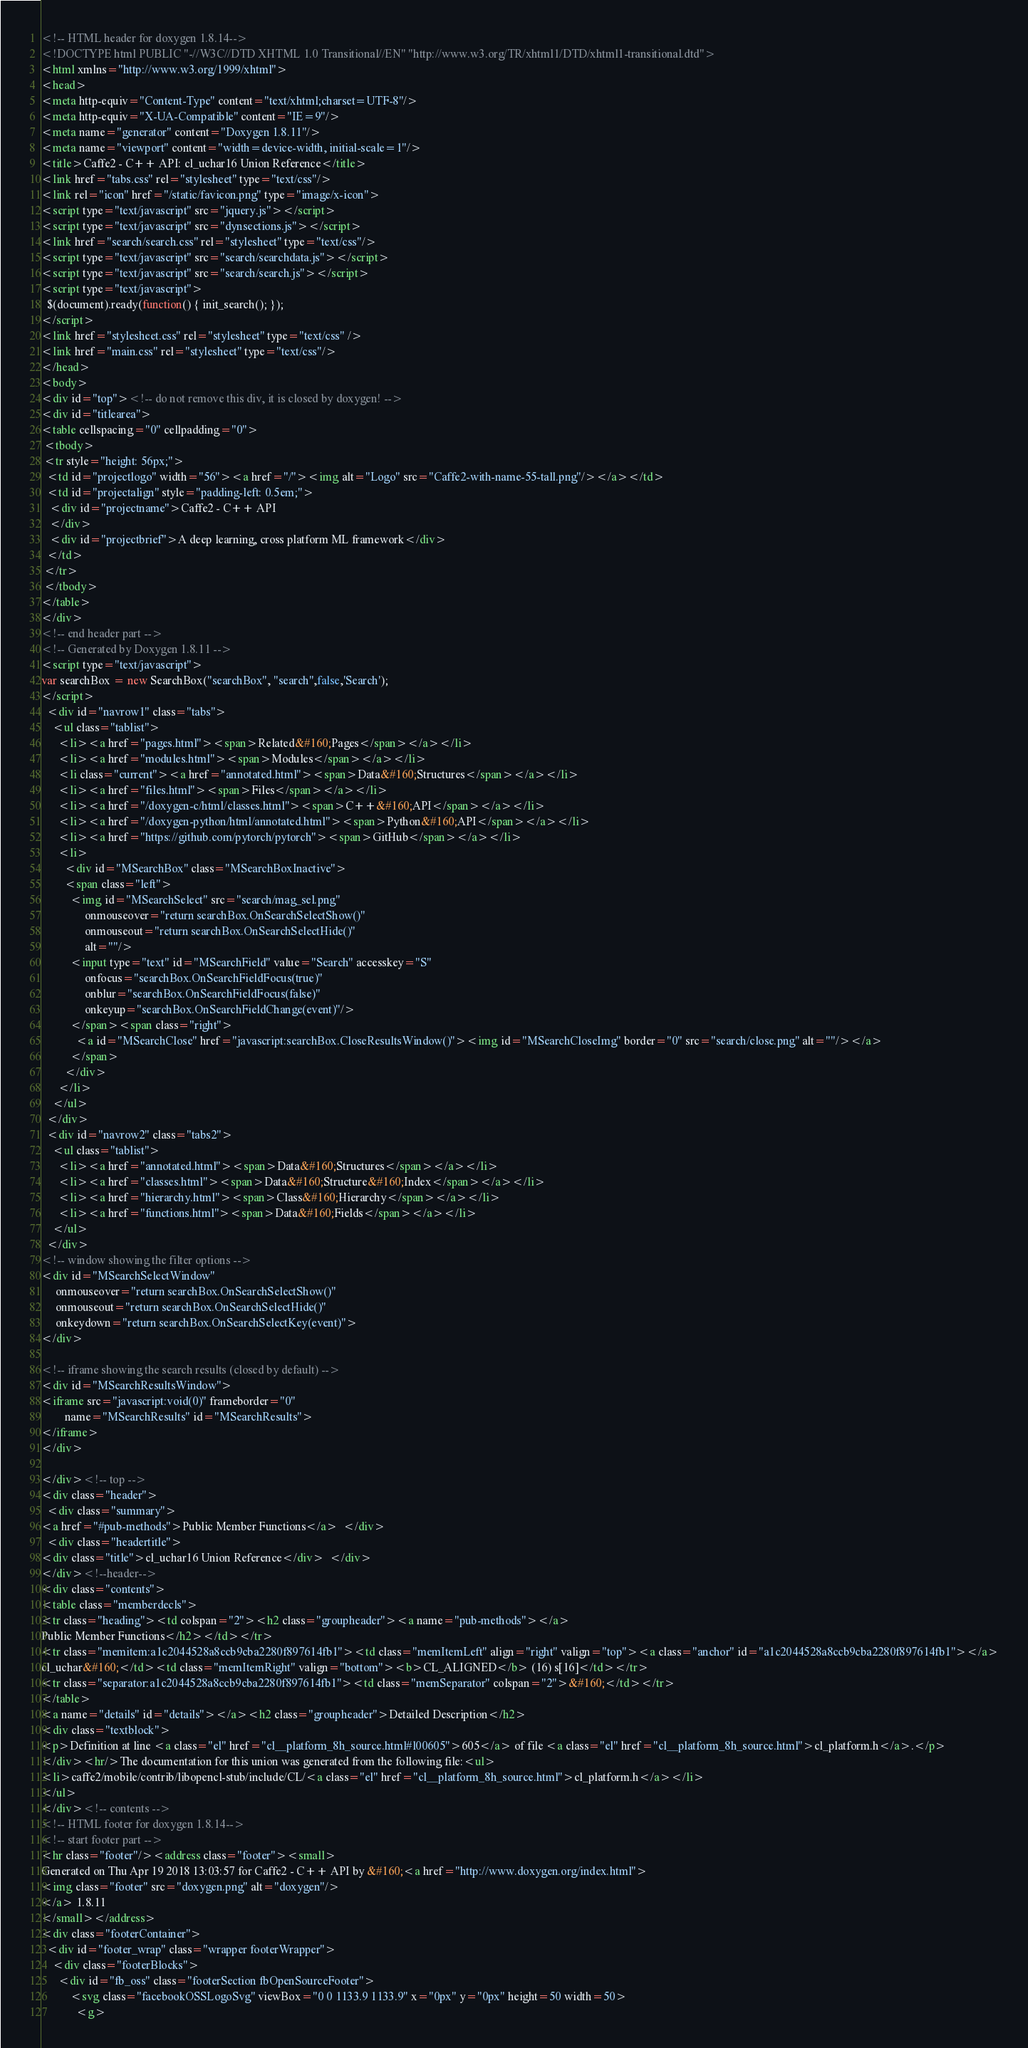<code> <loc_0><loc_0><loc_500><loc_500><_HTML_><!-- HTML header for doxygen 1.8.14-->
<!DOCTYPE html PUBLIC "-//W3C//DTD XHTML 1.0 Transitional//EN" "http://www.w3.org/TR/xhtml1/DTD/xhtml1-transitional.dtd">
<html xmlns="http://www.w3.org/1999/xhtml">
<head>
<meta http-equiv="Content-Type" content="text/xhtml;charset=UTF-8"/>
<meta http-equiv="X-UA-Compatible" content="IE=9"/>
<meta name="generator" content="Doxygen 1.8.11"/>
<meta name="viewport" content="width=device-width, initial-scale=1"/>
<title>Caffe2 - C++ API: cl_uchar16 Union Reference</title>
<link href="tabs.css" rel="stylesheet" type="text/css"/>
<link rel="icon" href="/static/favicon.png" type="image/x-icon">
<script type="text/javascript" src="jquery.js"></script>
<script type="text/javascript" src="dynsections.js"></script>
<link href="search/search.css" rel="stylesheet" type="text/css"/>
<script type="text/javascript" src="search/searchdata.js"></script>
<script type="text/javascript" src="search/search.js"></script>
<script type="text/javascript">
  $(document).ready(function() { init_search(); });
</script>
<link href="stylesheet.css" rel="stylesheet" type="text/css" />
<link href="main.css" rel="stylesheet" type="text/css"/>
</head>
<body>
<div id="top"><!-- do not remove this div, it is closed by doxygen! -->
<div id="titlearea">
<table cellspacing="0" cellpadding="0">
 <tbody>
 <tr style="height: 56px;">
  <td id="projectlogo" width="56"><a href="/"><img alt="Logo" src="Caffe2-with-name-55-tall.png"/></a></td>
  <td id="projectalign" style="padding-left: 0.5em;">
   <div id="projectname">Caffe2 - C++ API
   </div>
   <div id="projectbrief">A deep learning, cross platform ML framework</div>
  </td>
 </tr>
 </tbody>
</table>
</div>
<!-- end header part -->
<!-- Generated by Doxygen 1.8.11 -->
<script type="text/javascript">
var searchBox = new SearchBox("searchBox", "search",false,'Search');
</script>
  <div id="navrow1" class="tabs">
    <ul class="tablist">
      <li><a href="pages.html"><span>Related&#160;Pages</span></a></li>
      <li><a href="modules.html"><span>Modules</span></a></li>
      <li class="current"><a href="annotated.html"><span>Data&#160;Structures</span></a></li>
      <li><a href="files.html"><span>Files</span></a></li>
      <li><a href="/doxygen-c/html/classes.html"><span>C++&#160;API</span></a></li>
      <li><a href="/doxygen-python/html/annotated.html"><span>Python&#160;API</span></a></li>
      <li><a href="https://github.com/pytorch/pytorch"><span>GitHub</span></a></li>
      <li>
        <div id="MSearchBox" class="MSearchBoxInactive">
        <span class="left">
          <img id="MSearchSelect" src="search/mag_sel.png"
               onmouseover="return searchBox.OnSearchSelectShow()"
               onmouseout="return searchBox.OnSearchSelectHide()"
               alt=""/>
          <input type="text" id="MSearchField" value="Search" accesskey="S"
               onfocus="searchBox.OnSearchFieldFocus(true)" 
               onblur="searchBox.OnSearchFieldFocus(false)" 
               onkeyup="searchBox.OnSearchFieldChange(event)"/>
          </span><span class="right">
            <a id="MSearchClose" href="javascript:searchBox.CloseResultsWindow()"><img id="MSearchCloseImg" border="0" src="search/close.png" alt=""/></a>
          </span>
        </div>
      </li>
    </ul>
  </div>
  <div id="navrow2" class="tabs2">
    <ul class="tablist">
      <li><a href="annotated.html"><span>Data&#160;Structures</span></a></li>
      <li><a href="classes.html"><span>Data&#160;Structure&#160;Index</span></a></li>
      <li><a href="hierarchy.html"><span>Class&#160;Hierarchy</span></a></li>
      <li><a href="functions.html"><span>Data&#160;Fields</span></a></li>
    </ul>
  </div>
<!-- window showing the filter options -->
<div id="MSearchSelectWindow"
     onmouseover="return searchBox.OnSearchSelectShow()"
     onmouseout="return searchBox.OnSearchSelectHide()"
     onkeydown="return searchBox.OnSearchSelectKey(event)">
</div>

<!-- iframe showing the search results (closed by default) -->
<div id="MSearchResultsWindow">
<iframe src="javascript:void(0)" frameborder="0" 
        name="MSearchResults" id="MSearchResults">
</iframe>
</div>

</div><!-- top -->
<div class="header">
  <div class="summary">
<a href="#pub-methods">Public Member Functions</a>  </div>
  <div class="headertitle">
<div class="title">cl_uchar16 Union Reference</div>  </div>
</div><!--header-->
<div class="contents">
<table class="memberdecls">
<tr class="heading"><td colspan="2"><h2 class="groupheader"><a name="pub-methods"></a>
Public Member Functions</h2></td></tr>
<tr class="memitem:a1c2044528a8ccb9cba2280f897614fb1"><td class="memItemLeft" align="right" valign="top"><a class="anchor" id="a1c2044528a8ccb9cba2280f897614fb1"></a>
cl_uchar&#160;</td><td class="memItemRight" valign="bottom"><b>CL_ALIGNED</b> (16) s[16]</td></tr>
<tr class="separator:a1c2044528a8ccb9cba2280f897614fb1"><td class="memSeparator" colspan="2">&#160;</td></tr>
</table>
<a name="details" id="details"></a><h2 class="groupheader">Detailed Description</h2>
<div class="textblock">
<p>Definition at line <a class="el" href="cl__platform_8h_source.html#l00605">605</a> of file <a class="el" href="cl__platform_8h_source.html">cl_platform.h</a>.</p>
</div><hr/>The documentation for this union was generated from the following file:<ul>
<li>caffe2/mobile/contrib/libopencl-stub/include/CL/<a class="el" href="cl__platform_8h_source.html">cl_platform.h</a></li>
</ul>
</div><!-- contents -->
<!-- HTML footer for doxygen 1.8.14-->
<!-- start footer part -->
<hr class="footer"/><address class="footer"><small>
Generated on Thu Apr 19 2018 13:03:57 for Caffe2 - C++ API by &#160;<a href="http://www.doxygen.org/index.html">
<img class="footer" src="doxygen.png" alt="doxygen"/>
</a> 1.8.11
</small></address>
<div class="footerContainer">
  <div id="footer_wrap" class="wrapper footerWrapper">
    <div class="footerBlocks">
      <div id="fb_oss" class="footerSection fbOpenSourceFooter">
          <svg class="facebookOSSLogoSvg" viewBox="0 0 1133.9 1133.9" x="0px" y="0px" height=50 width=50>
            <g></code> 